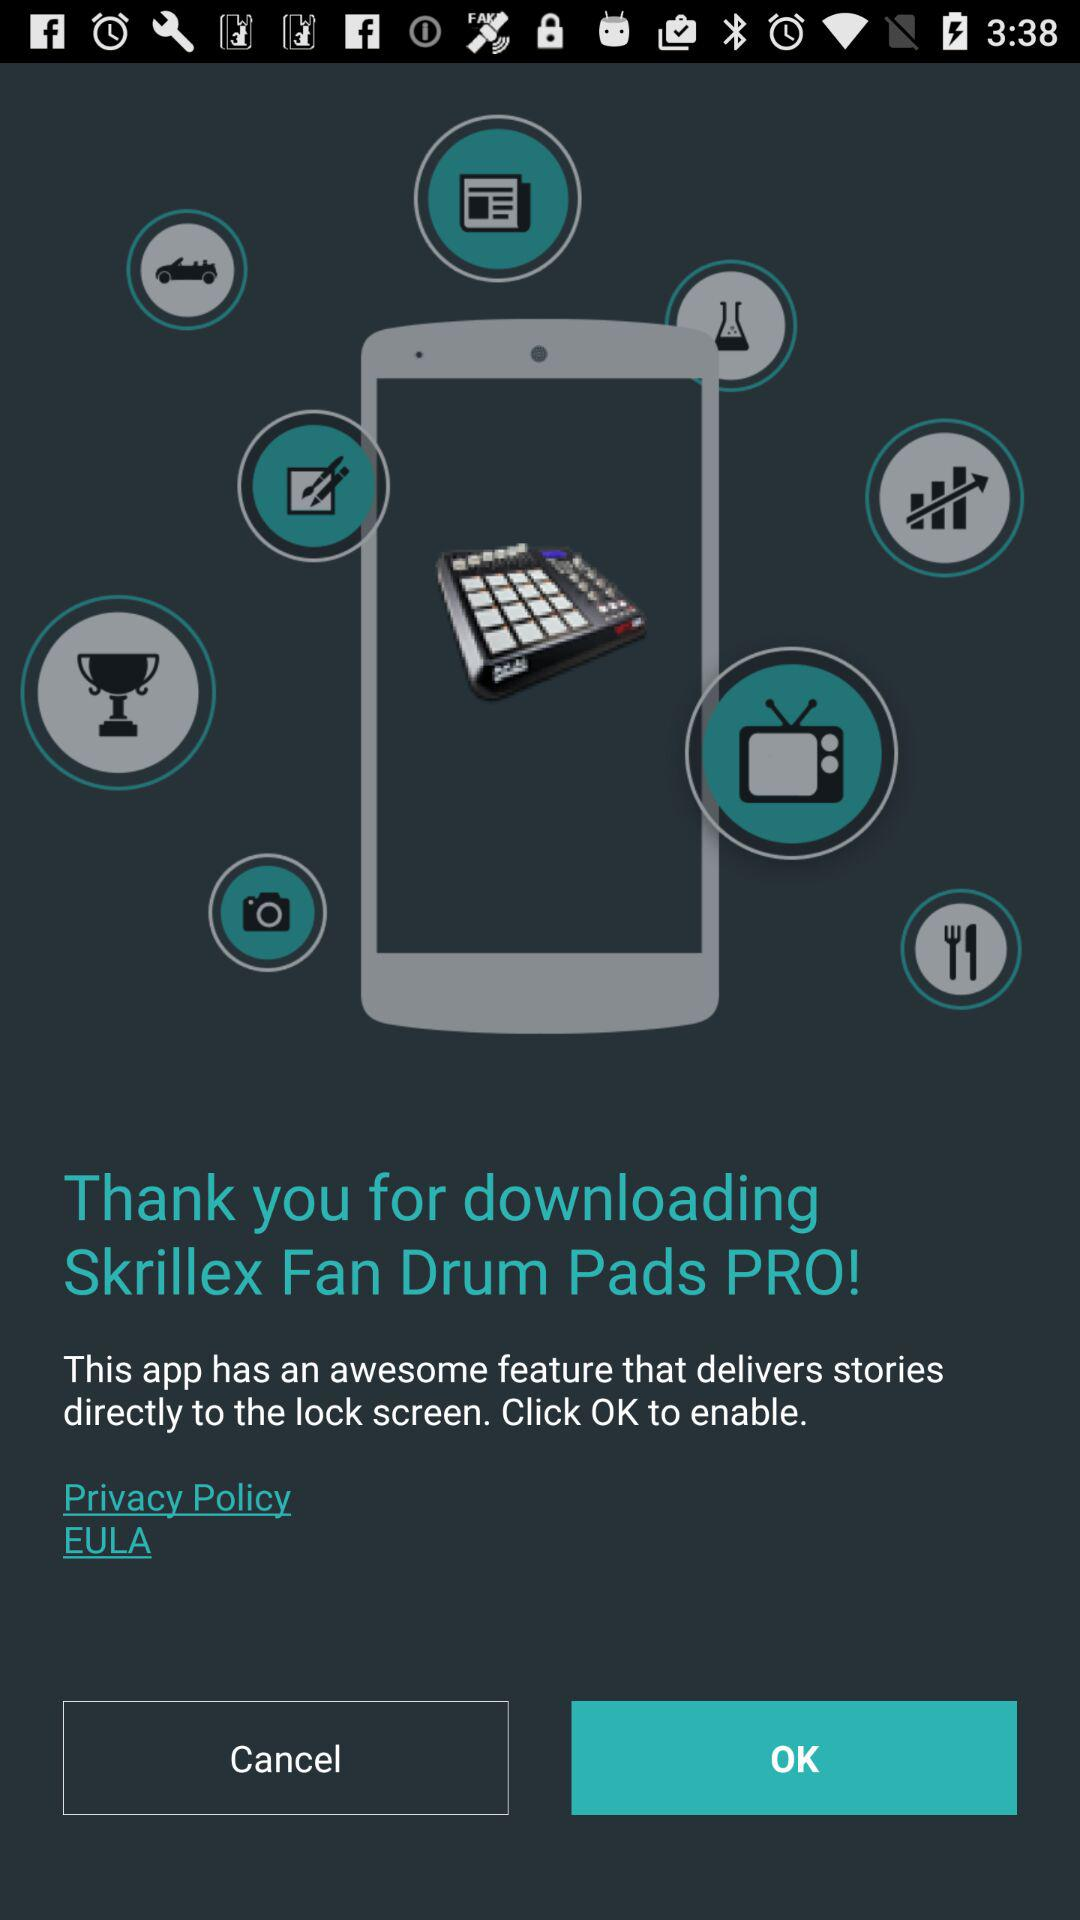What is the application name? The application name is Skrillex Fan Drum Pads. 